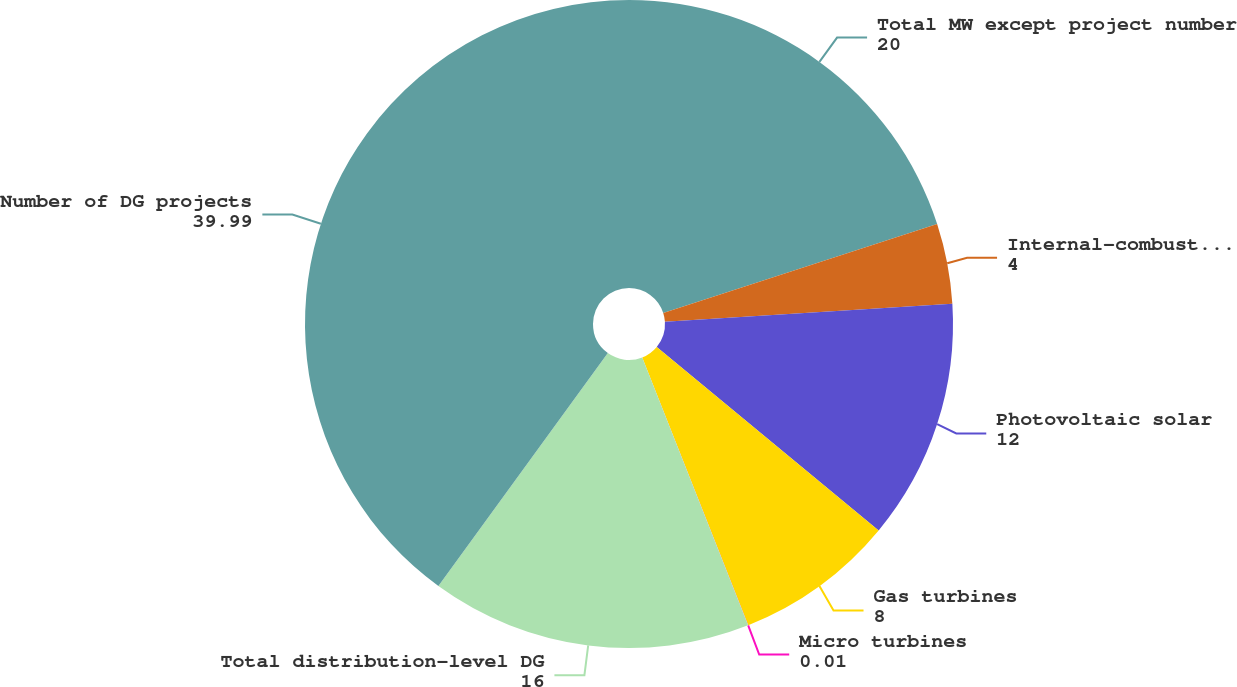Convert chart. <chart><loc_0><loc_0><loc_500><loc_500><pie_chart><fcel>Total MW except project number<fcel>Internal-combustion engines<fcel>Photovoltaic solar<fcel>Gas turbines<fcel>Micro turbines<fcel>Total distribution-level DG<fcel>Number of DG projects<nl><fcel>20.0%<fcel>4.0%<fcel>12.0%<fcel>8.0%<fcel>0.01%<fcel>16.0%<fcel>39.99%<nl></chart> 